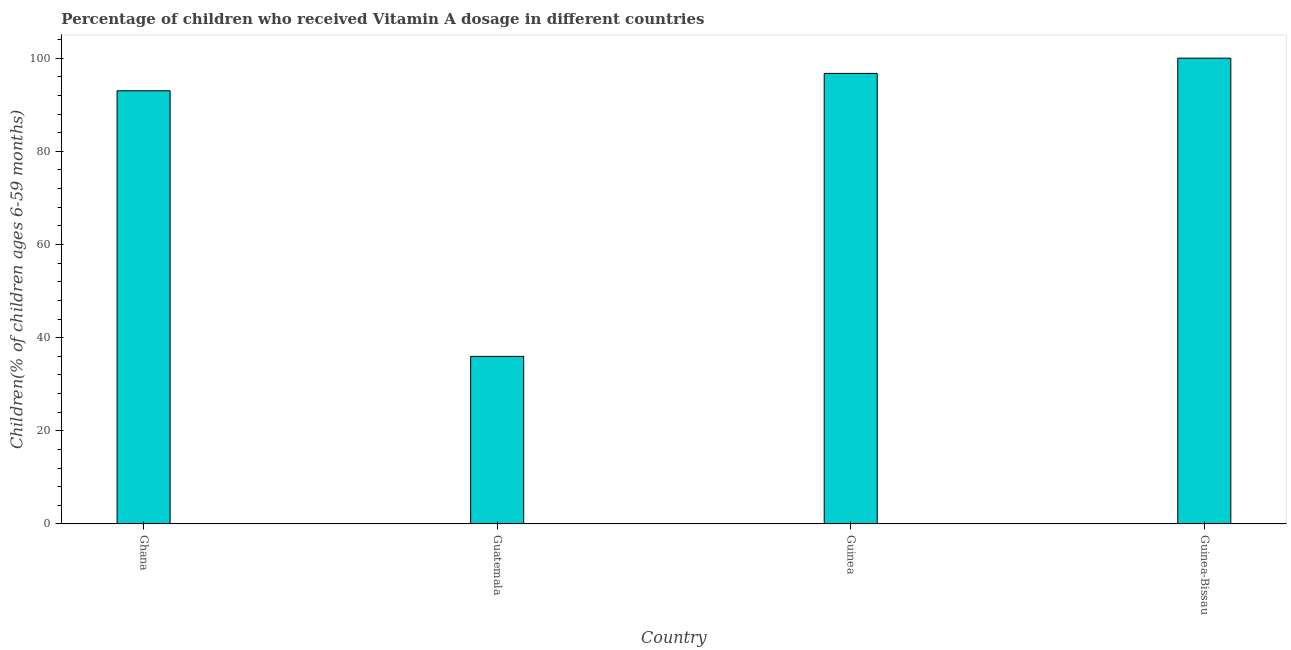Does the graph contain any zero values?
Give a very brief answer. No. What is the title of the graph?
Provide a short and direct response. Percentage of children who received Vitamin A dosage in different countries. What is the label or title of the X-axis?
Your answer should be compact. Country. What is the label or title of the Y-axis?
Keep it short and to the point. Children(% of children ages 6-59 months). Across all countries, what is the maximum vitamin a supplementation coverage rate?
Provide a succinct answer. 100. Across all countries, what is the minimum vitamin a supplementation coverage rate?
Offer a terse response. 35.98. In which country was the vitamin a supplementation coverage rate maximum?
Your answer should be compact. Guinea-Bissau. In which country was the vitamin a supplementation coverage rate minimum?
Give a very brief answer. Guatemala. What is the sum of the vitamin a supplementation coverage rate?
Ensure brevity in your answer.  325.7. What is the difference between the vitamin a supplementation coverage rate in Guatemala and Guinea-Bissau?
Offer a very short reply. -64.03. What is the average vitamin a supplementation coverage rate per country?
Provide a succinct answer. 81.42. What is the median vitamin a supplementation coverage rate?
Keep it short and to the point. 94.86. What is the ratio of the vitamin a supplementation coverage rate in Ghana to that in Guatemala?
Your answer should be very brief. 2.58. What is the difference between the highest and the second highest vitamin a supplementation coverage rate?
Your response must be concise. 3.27. Is the sum of the vitamin a supplementation coverage rate in Ghana and Guinea-Bissau greater than the maximum vitamin a supplementation coverage rate across all countries?
Your answer should be compact. Yes. What is the difference between the highest and the lowest vitamin a supplementation coverage rate?
Make the answer very short. 64.02. How many bars are there?
Your response must be concise. 4. Are all the bars in the graph horizontal?
Your answer should be compact. No. What is the difference between two consecutive major ticks on the Y-axis?
Offer a very short reply. 20. Are the values on the major ticks of Y-axis written in scientific E-notation?
Your answer should be compact. No. What is the Children(% of children ages 6-59 months) of Ghana?
Your response must be concise. 93. What is the Children(% of children ages 6-59 months) of Guatemala?
Offer a very short reply. 35.98. What is the Children(% of children ages 6-59 months) in Guinea?
Offer a very short reply. 96.73. What is the difference between the Children(% of children ages 6-59 months) in Ghana and Guatemala?
Your answer should be compact. 57.02. What is the difference between the Children(% of children ages 6-59 months) in Ghana and Guinea?
Make the answer very short. -3.73. What is the difference between the Children(% of children ages 6-59 months) in Guatemala and Guinea?
Keep it short and to the point. -60.75. What is the difference between the Children(% of children ages 6-59 months) in Guatemala and Guinea-Bissau?
Provide a short and direct response. -64.02. What is the difference between the Children(% of children ages 6-59 months) in Guinea and Guinea-Bissau?
Provide a short and direct response. -3.27. What is the ratio of the Children(% of children ages 6-59 months) in Ghana to that in Guatemala?
Keep it short and to the point. 2.58. What is the ratio of the Children(% of children ages 6-59 months) in Guatemala to that in Guinea?
Your answer should be compact. 0.37. What is the ratio of the Children(% of children ages 6-59 months) in Guatemala to that in Guinea-Bissau?
Make the answer very short. 0.36. What is the ratio of the Children(% of children ages 6-59 months) in Guinea to that in Guinea-Bissau?
Make the answer very short. 0.97. 